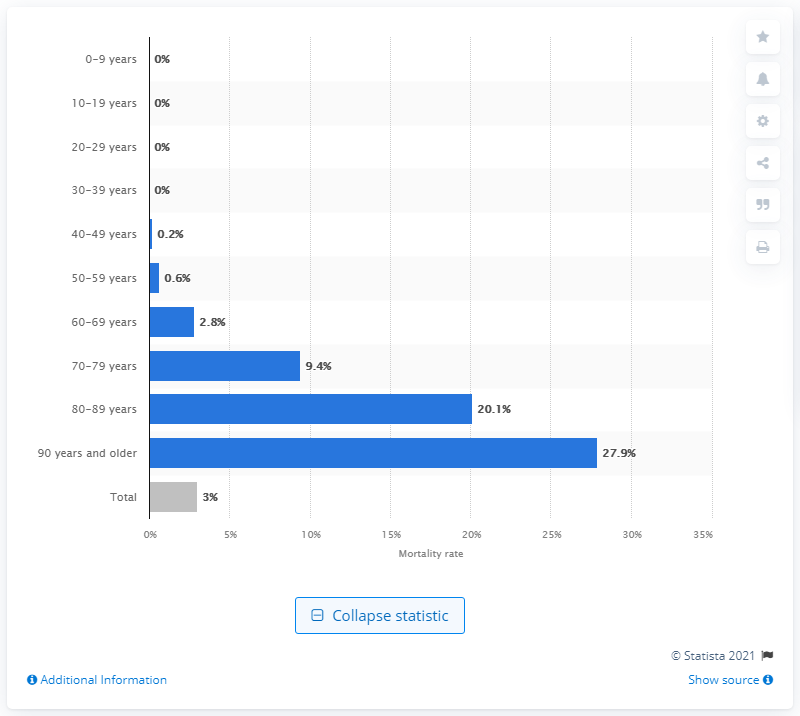Point out several critical features in this image. The death rate for individuals under the age of 60 was 27.9%. According to the latest data, the mortality rate of the coronavirus in Italy was 27.9%. The mortality rate for patients who are older than 90 years is 27.9%. According to data, the fatality rate for individuals between the ages of 80 and 89 is approximately 20.1%. 